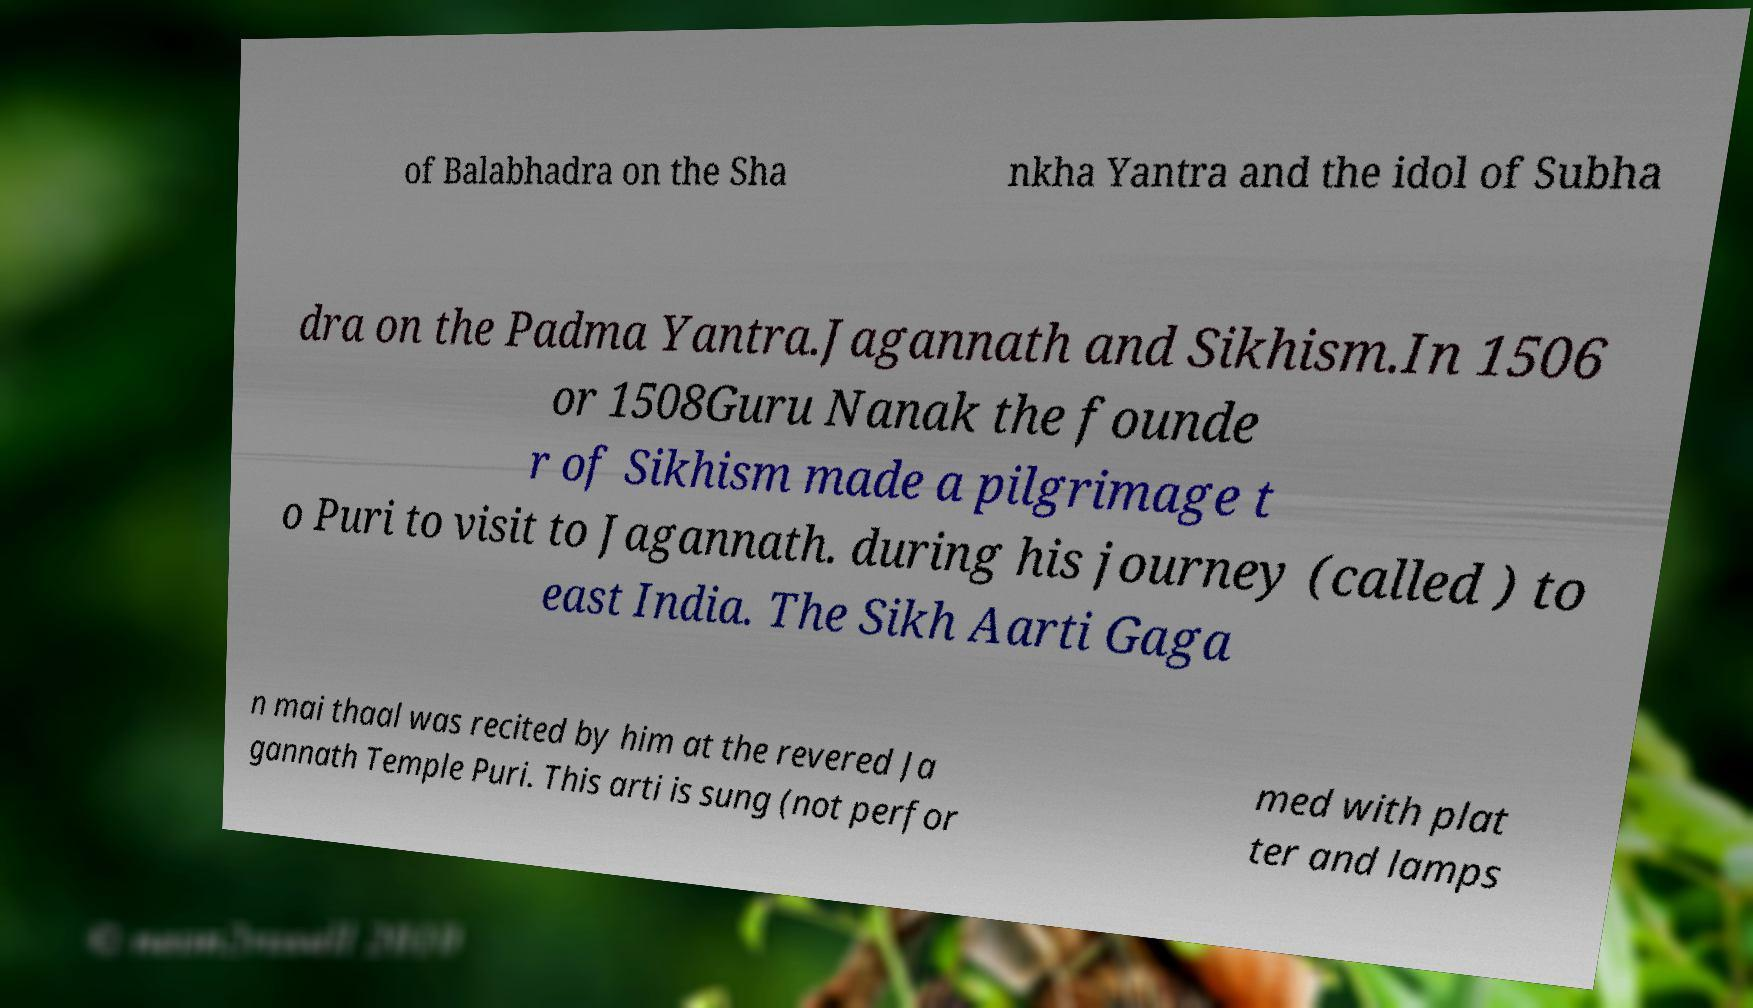What messages or text are displayed in this image? I need them in a readable, typed format. of Balabhadra on the Sha nkha Yantra and the idol of Subha dra on the Padma Yantra.Jagannath and Sikhism.In 1506 or 1508Guru Nanak the founde r of Sikhism made a pilgrimage t o Puri to visit to Jagannath. during his journey (called ) to east India. The Sikh Aarti Gaga n mai thaal was recited by him at the revered Ja gannath Temple Puri. This arti is sung (not perfor med with plat ter and lamps 